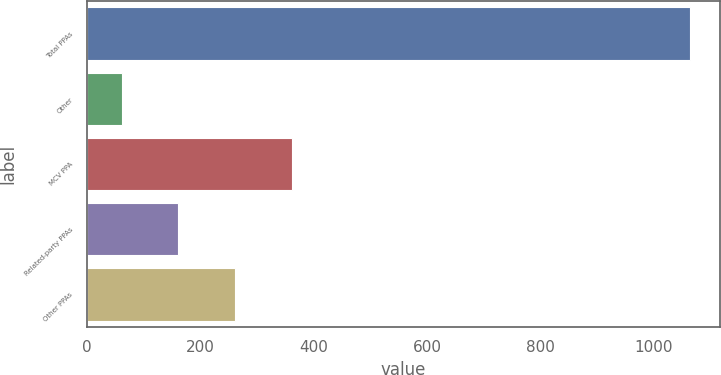Convert chart. <chart><loc_0><loc_0><loc_500><loc_500><bar_chart><fcel>Total PPAs<fcel>Other<fcel>MCV PPA<fcel>Related-party PPAs<fcel>Other PPAs<nl><fcel>1063<fcel>61<fcel>361.6<fcel>161.2<fcel>261.4<nl></chart> 